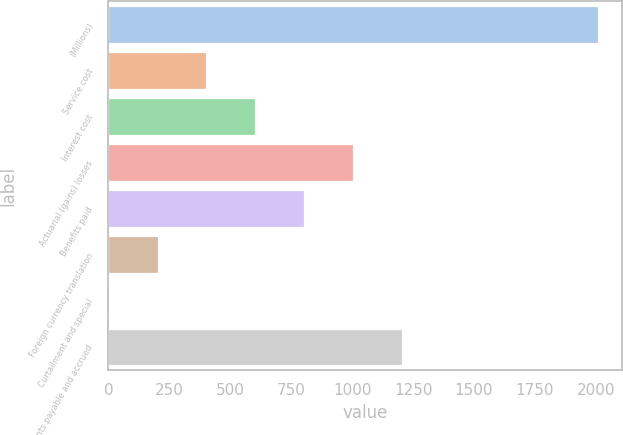<chart> <loc_0><loc_0><loc_500><loc_500><bar_chart><fcel>(Millions)<fcel>Service cost<fcel>Interest cost<fcel>Actuarial (gains) losses<fcel>Benefits paid<fcel>Foreign currency translation<fcel>Curtailment and special<fcel>Accounts payable and accrued<nl><fcel>2008<fcel>402.4<fcel>603.1<fcel>1004.5<fcel>803.8<fcel>201.7<fcel>1<fcel>1205.2<nl></chart> 